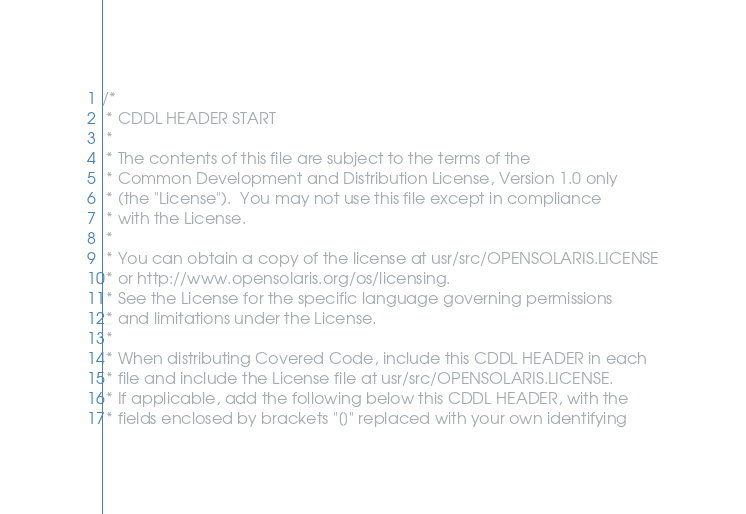<code> <loc_0><loc_0><loc_500><loc_500><_C_>/*
 * CDDL HEADER START
 *
 * The contents of this file are subject to the terms of the
 * Common Development and Distribution License, Version 1.0 only
 * (the "License").  You may not use this file except in compliance
 * with the License.
 *
 * You can obtain a copy of the license at usr/src/OPENSOLARIS.LICENSE
 * or http://www.opensolaris.org/os/licensing.
 * See the License for the specific language governing permissions
 * and limitations under the License.
 *
 * When distributing Covered Code, include this CDDL HEADER in each
 * file and include the License file at usr/src/OPENSOLARIS.LICENSE.
 * If applicable, add the following below this CDDL HEADER, with the
 * fields enclosed by brackets "[]" replaced with your own identifying</code> 